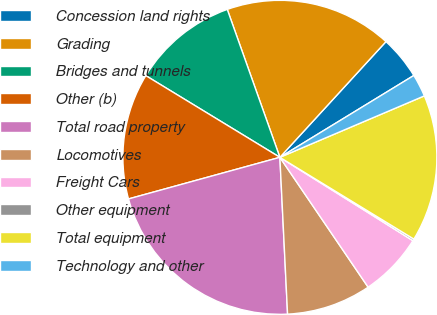<chart> <loc_0><loc_0><loc_500><loc_500><pie_chart><fcel>Concession land rights<fcel>Grading<fcel>Bridges and tunnels<fcel>Other (b)<fcel>Total road property<fcel>Locomotives<fcel>Freight Cars<fcel>Other equipment<fcel>Total equipment<fcel>Technology and other<nl><fcel>4.46%<fcel>17.25%<fcel>10.85%<fcel>12.98%<fcel>21.51%<fcel>8.72%<fcel>6.59%<fcel>0.19%<fcel>15.12%<fcel>2.33%<nl></chart> 